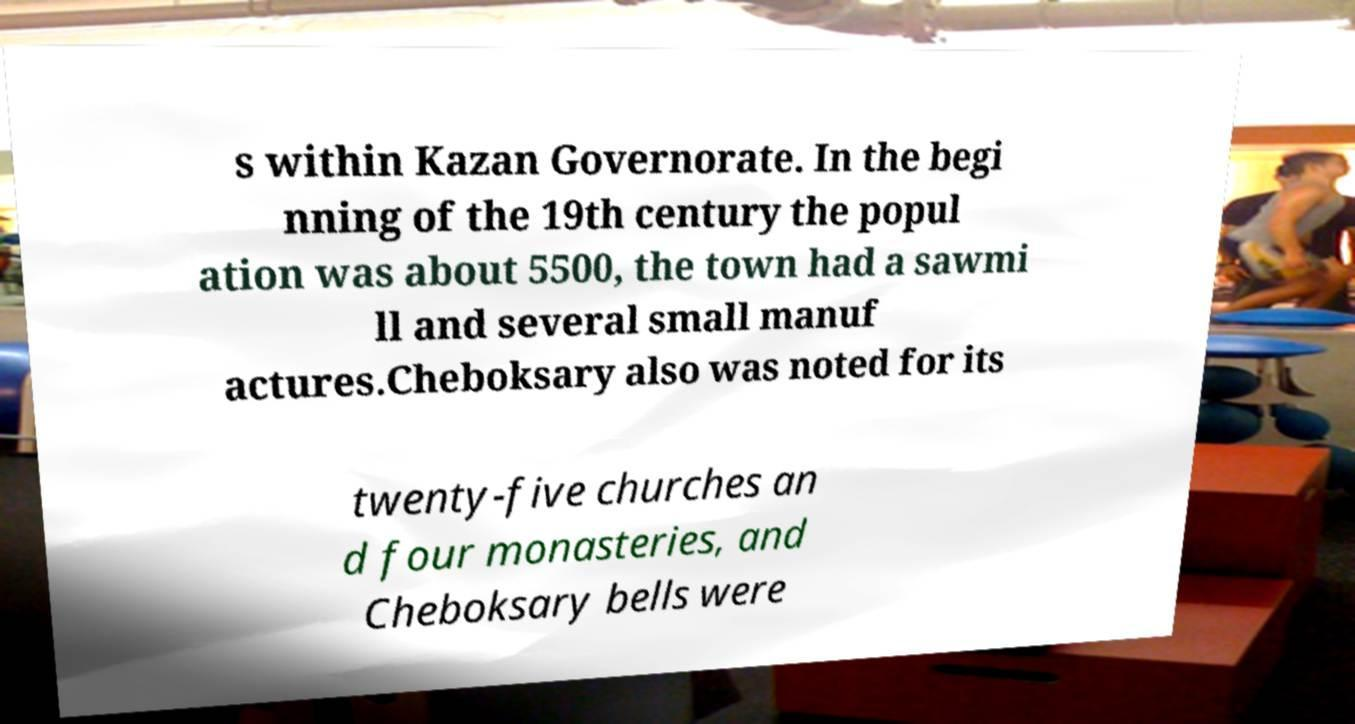Please identify and transcribe the text found in this image. s within Kazan Governorate. In the begi nning of the 19th century the popul ation was about 5500, the town had a sawmi ll and several small manuf actures.Cheboksary also was noted for its twenty-five churches an d four monasteries, and Cheboksary bells were 